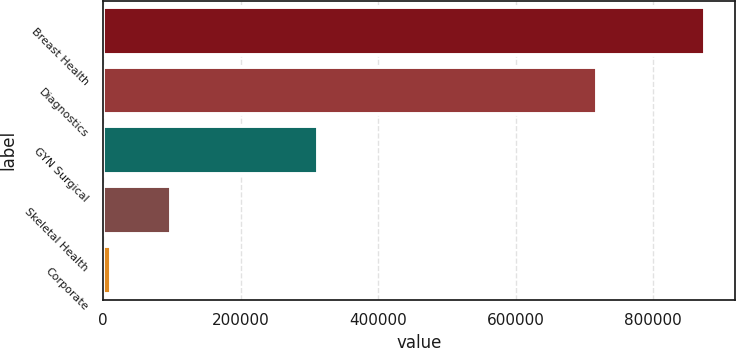Convert chart to OTSL. <chart><loc_0><loc_0><loc_500><loc_500><bar_chart><fcel>Breast Health<fcel>Diagnostics<fcel>GYN Surgical<fcel>Skeletal Health<fcel>Corporate<nl><fcel>875771<fcel>718064<fcel>313089<fcel>98025.2<fcel>11609<nl></chart> 